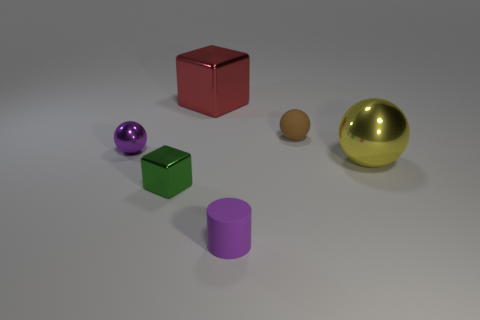Add 1 tiny purple rubber things. How many objects exist? 7 Subtract all blocks. How many objects are left? 4 Subtract all small green metallic things. Subtract all tiny shiny things. How many objects are left? 3 Add 6 tiny purple things. How many tiny purple things are left? 8 Add 3 tiny cylinders. How many tiny cylinders exist? 4 Subtract 1 purple cylinders. How many objects are left? 5 